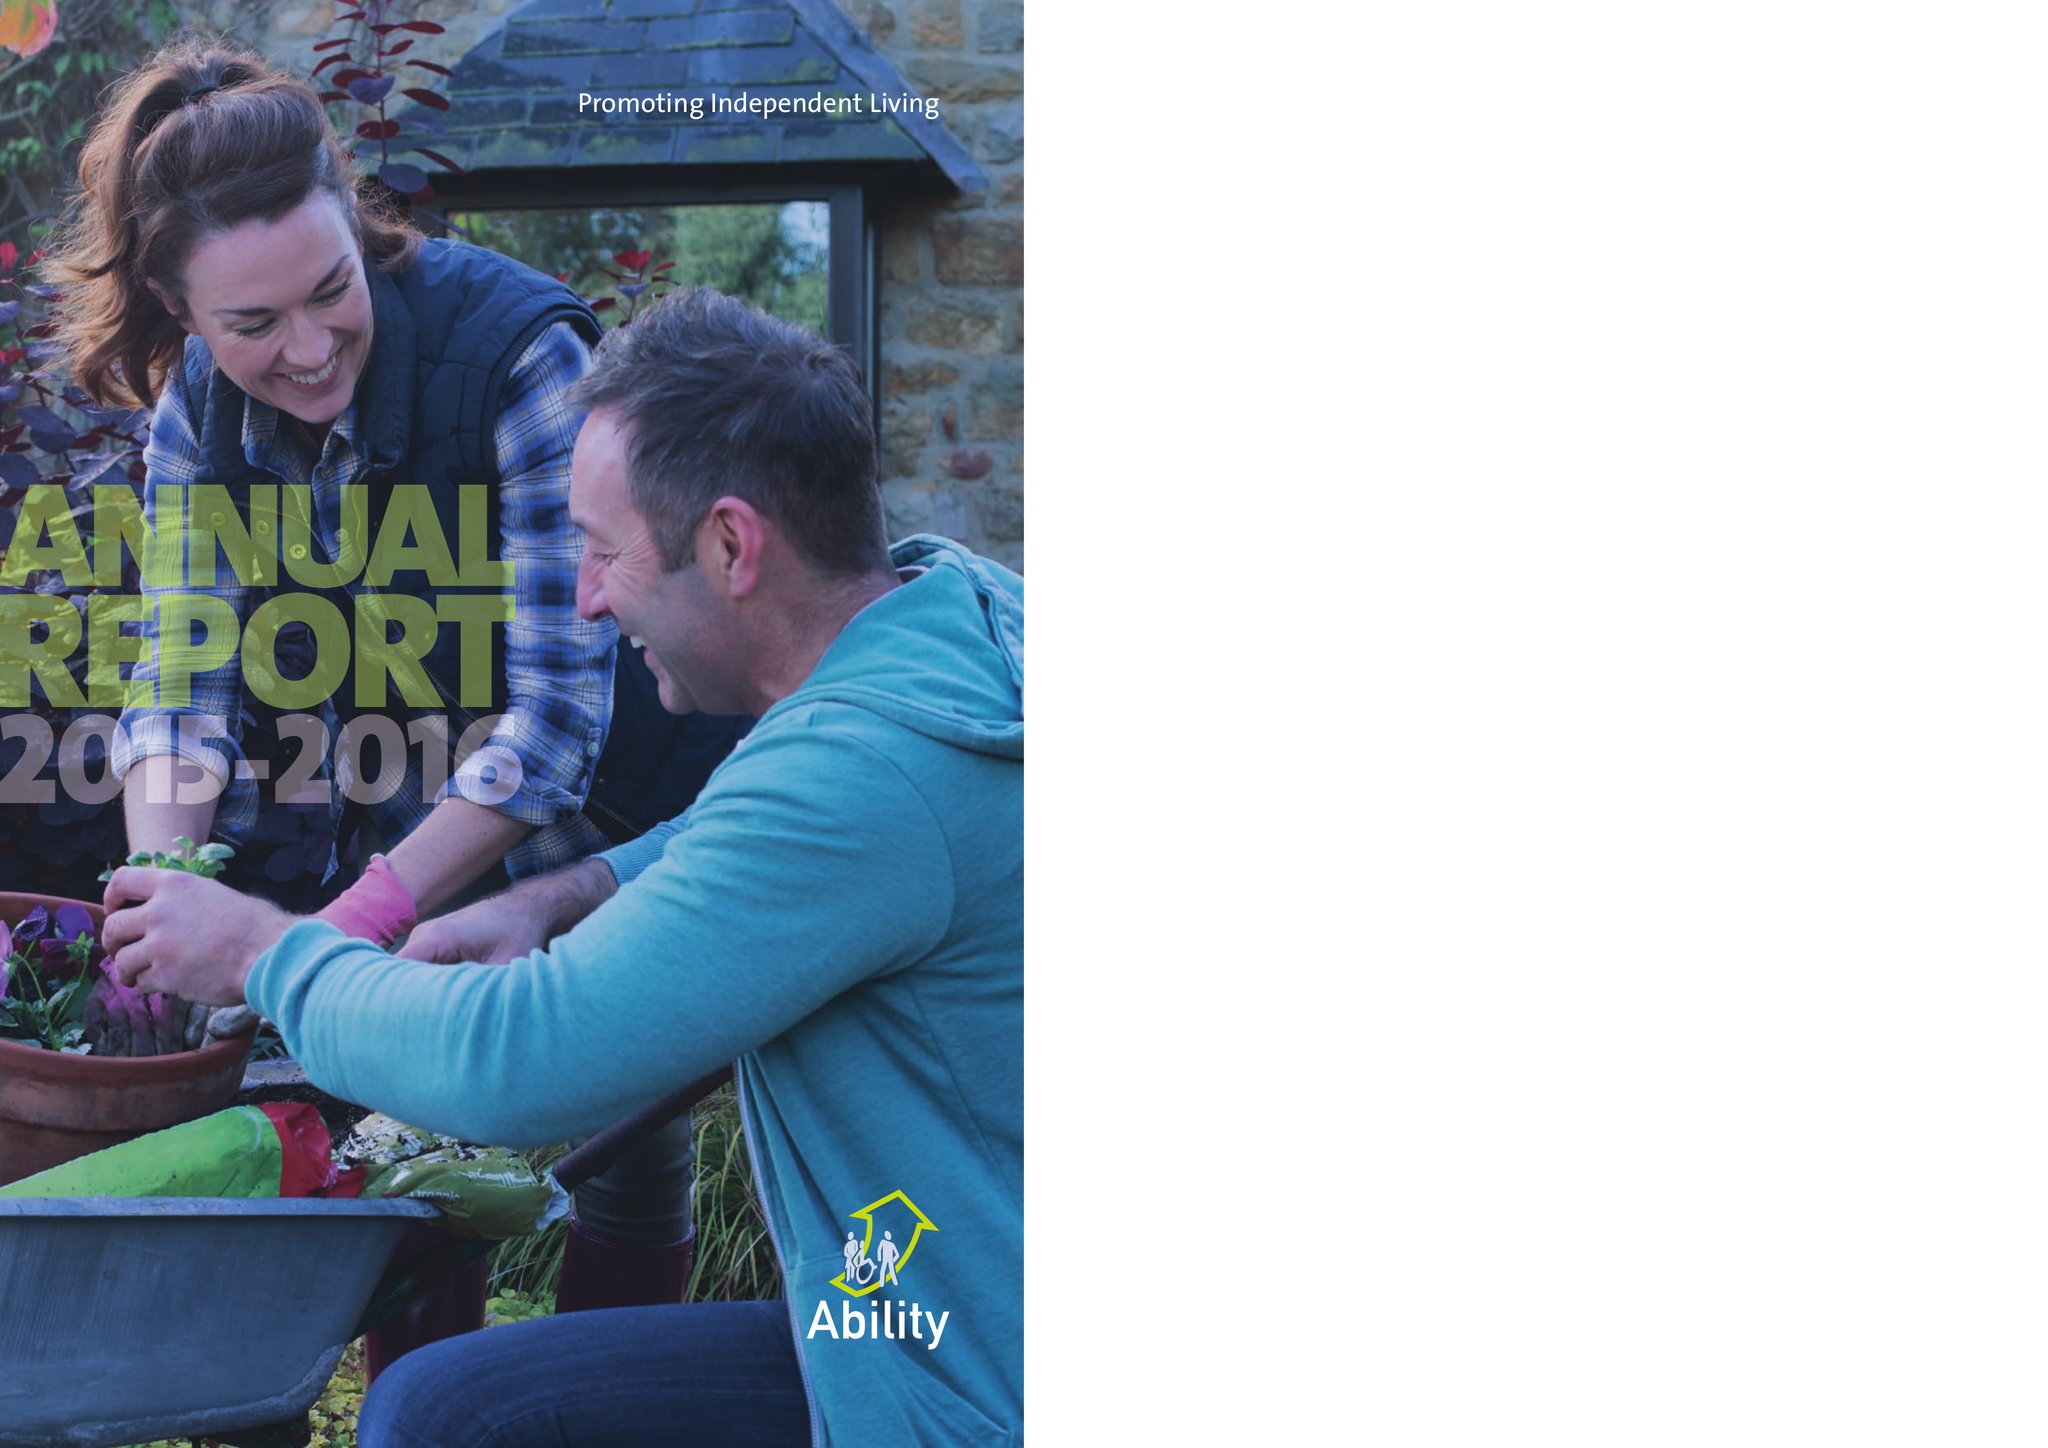What is the value for the address__post_town?
Answer the question using a single word or phrase. STAINES-UPON-THAMES[11] 